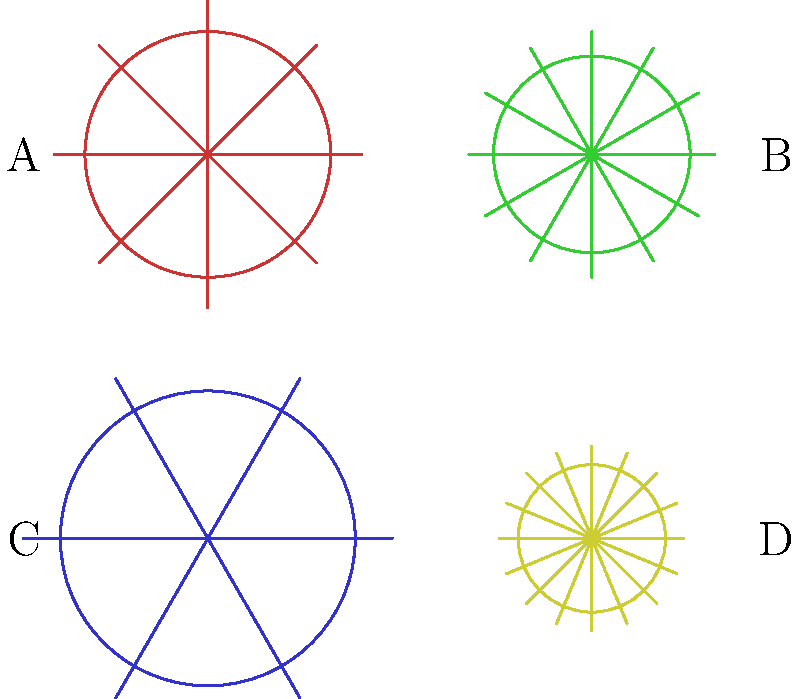In the context of managing daily tasks with limited energy, imagine these gears represent different aspects of your routine. Which gear type would be most suitable for transferring high torque at low speeds, similar to how you might need to conserve energy while still accomplishing important tasks? To answer this question, let's analyze the characteristics of each gear type shown in the image and relate them to the concept of transferring high torque at low speeds:

1. Gear A: This gear has 8 teeth and a large diameter. It represents a spur gear, which is commonly used for general-purpose applications.

2. Gear B: With 12 teeth and a smaller diameter, this gear could represent a pinion gear, often used in conjunction with larger gears for speed reduction or torque increase.

3. Gear C: This gear has 6 teeth and the largest diameter. It resembles a spur gear with fewer, larger teeth, which is characteristic of a gear designed for high torque applications.

4. Gear D: With 16 teeth and the smallest diameter, this gear likely represents a high-speed, low-torque application.

For transferring high torque at low speeds, we need a gear with fewer, larger teeth. This design allows for greater force to be applied to each tooth, resulting in higher torque transfer. Additionally, fewer teeth mean the gear will rotate more slowly for a given input speed.

Gear C best fits this description, with its 6 large teeth and biggest diameter. This type of gear would be most suitable for applications requiring high torque at low speeds, similar to how you might need to approach tasks that require significant effort but must be done at a slower pace to conserve energy.
Answer: Gear C 